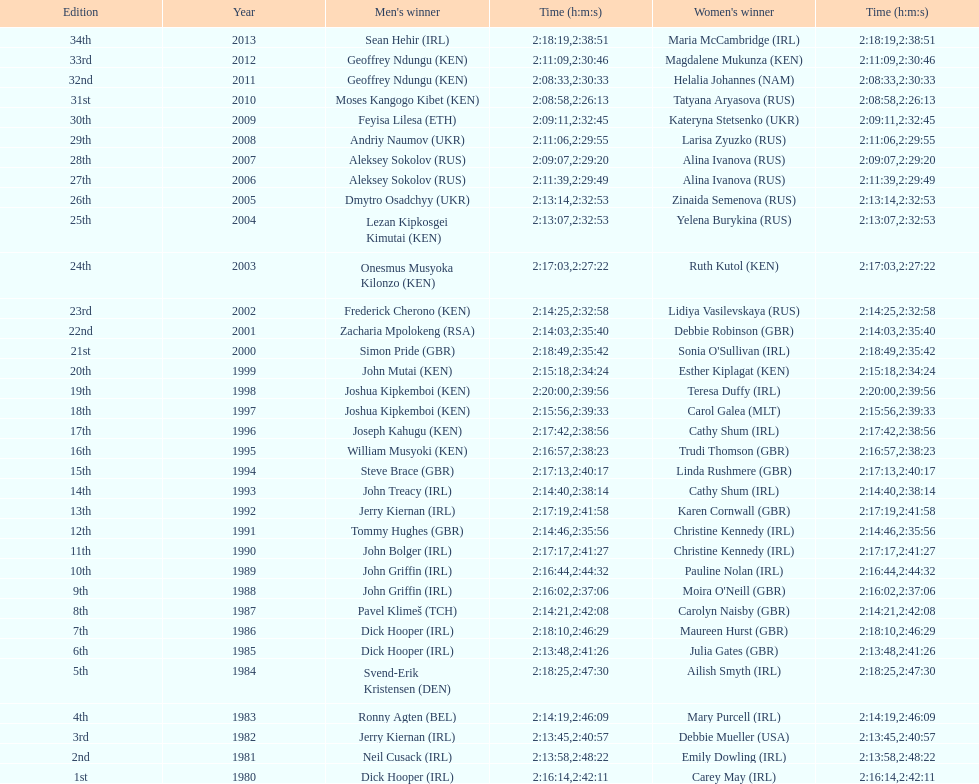Who had the most amount of time out of all the runners? Maria McCambridge (IRL). 